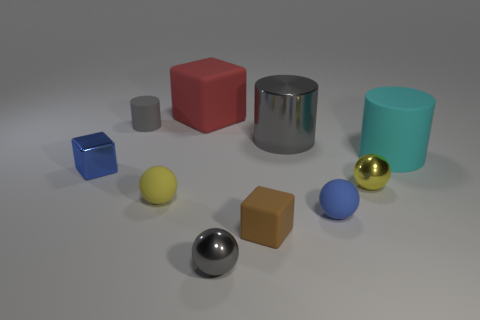Subtract all small gray metal balls. How many balls are left? 3 Subtract all blue spheres. How many spheres are left? 3 Subtract all cylinders. How many objects are left? 7 Subtract 1 cylinders. How many cylinders are left? 2 Subtract all yellow cylinders. Subtract all red blocks. How many cylinders are left? 3 Subtract all cyan cylinders. How many gray balls are left? 1 Subtract all cyan matte cylinders. Subtract all brown objects. How many objects are left? 8 Add 1 small matte objects. How many small matte objects are left? 5 Add 5 tiny gray shiny objects. How many tiny gray shiny objects exist? 6 Subtract 0 purple cubes. How many objects are left? 10 